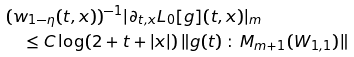<formula> <loc_0><loc_0><loc_500><loc_500>& ( w _ { 1 - \eta } ( t , x ) ) ^ { - 1 } | \partial _ { t , x } L _ { 0 } [ g ] ( t , x ) | _ { m } \\ & \quad \leq C \log ( 2 + t + | x | ) \, \| g ( t ) \, \colon \, { M _ { m + 1 } ( W _ { 1 , 1 } ) } \|</formula> 